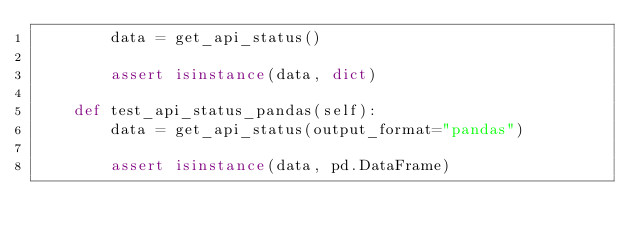<code> <loc_0><loc_0><loc_500><loc_500><_Python_>        data = get_api_status()

        assert isinstance(data, dict)

    def test_api_status_pandas(self):
        data = get_api_status(output_format="pandas")

        assert isinstance(data, pd.DataFrame)
</code> 